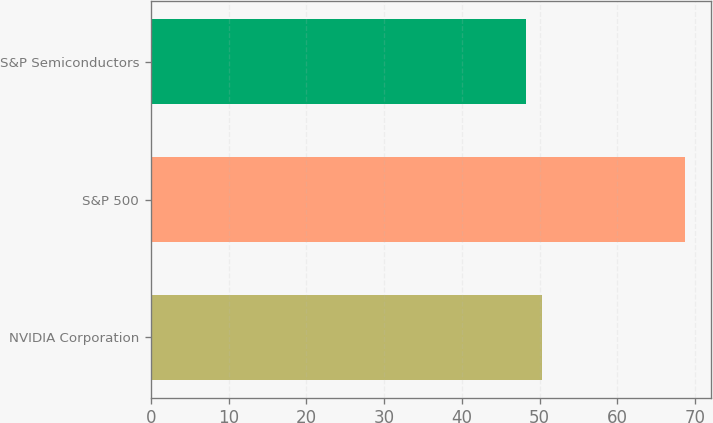Convert chart to OTSL. <chart><loc_0><loc_0><loc_500><loc_500><bar_chart><fcel>NVIDIA Corporation<fcel>S&P 500<fcel>S&P Semiconductors<nl><fcel>50.34<fcel>68.65<fcel>48.31<nl></chart> 